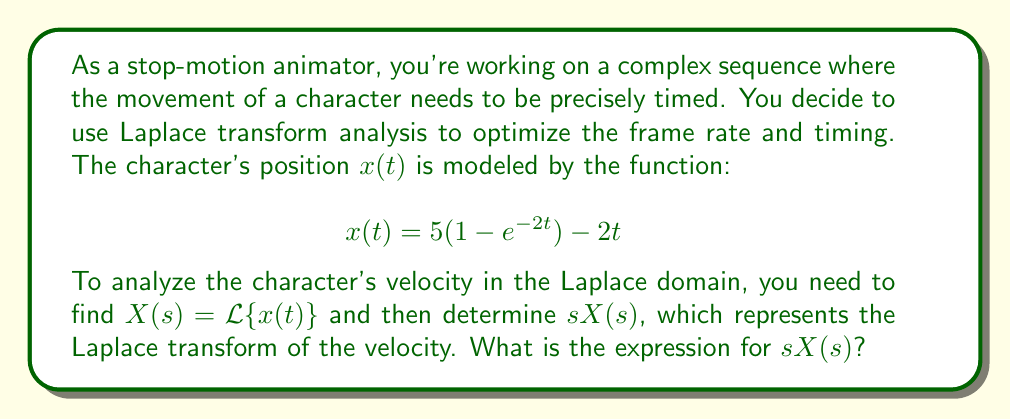Teach me how to tackle this problem. To solve this problem, we'll follow these steps:

1) First, let's find the Laplace transform of $x(t)$. We'll do this term by term:

   a) For $5(1 - e^{-2t})$:
      $\mathcal{L}\{5\} = \frac{5}{s}$
      $\mathcal{L}\{-5e^{-2t}\} = -\frac{5}{s+2}$

   b) For $-2t$:
      $\mathcal{L}\{-2t\} = -\frac{2}{s^2}$

2) Combining these terms:

   $$X(s) = \frac{5}{s} - \frac{5}{s+2} - \frac{2}{s^2}$$

3) To find the Laplace transform of the velocity, we multiply $X(s)$ by $s$:

   $$sX(s) = s(\frac{5}{s} - \frac{5}{s+2} - \frac{2}{s^2})$$

4) Simplify:

   $$sX(s) = 5 - \frac{5s}{s+2} - \frac{2}{s}$$

5) Find a common denominator:

   $$sX(s) = \frac{5s(s+2) - 5s^2 - 2(s+2)}{s(s+2)}$$

6) Expand the numerator:

   $$sX(s) = \frac{5s^2 + 10s - 5s^2 - 2s - 4}{s(s+2)}$$

7) Simplify:

   $$sX(s) = \frac{8s - 4}{s(s+2)}$$

This is our final expression for $sX(s)$.
Answer: $$sX(s) = \frac{8s - 4}{s(s+2)}$$ 